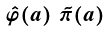Convert formula to latex. <formula><loc_0><loc_0><loc_500><loc_500>\begin{smallmatrix} \hat { \varphi } ( a ) & \tilde { \pi } ( a ) \end{smallmatrix}</formula> 